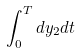<formula> <loc_0><loc_0><loc_500><loc_500>\int _ { 0 } ^ { T } d y _ { 2 } d t</formula> 